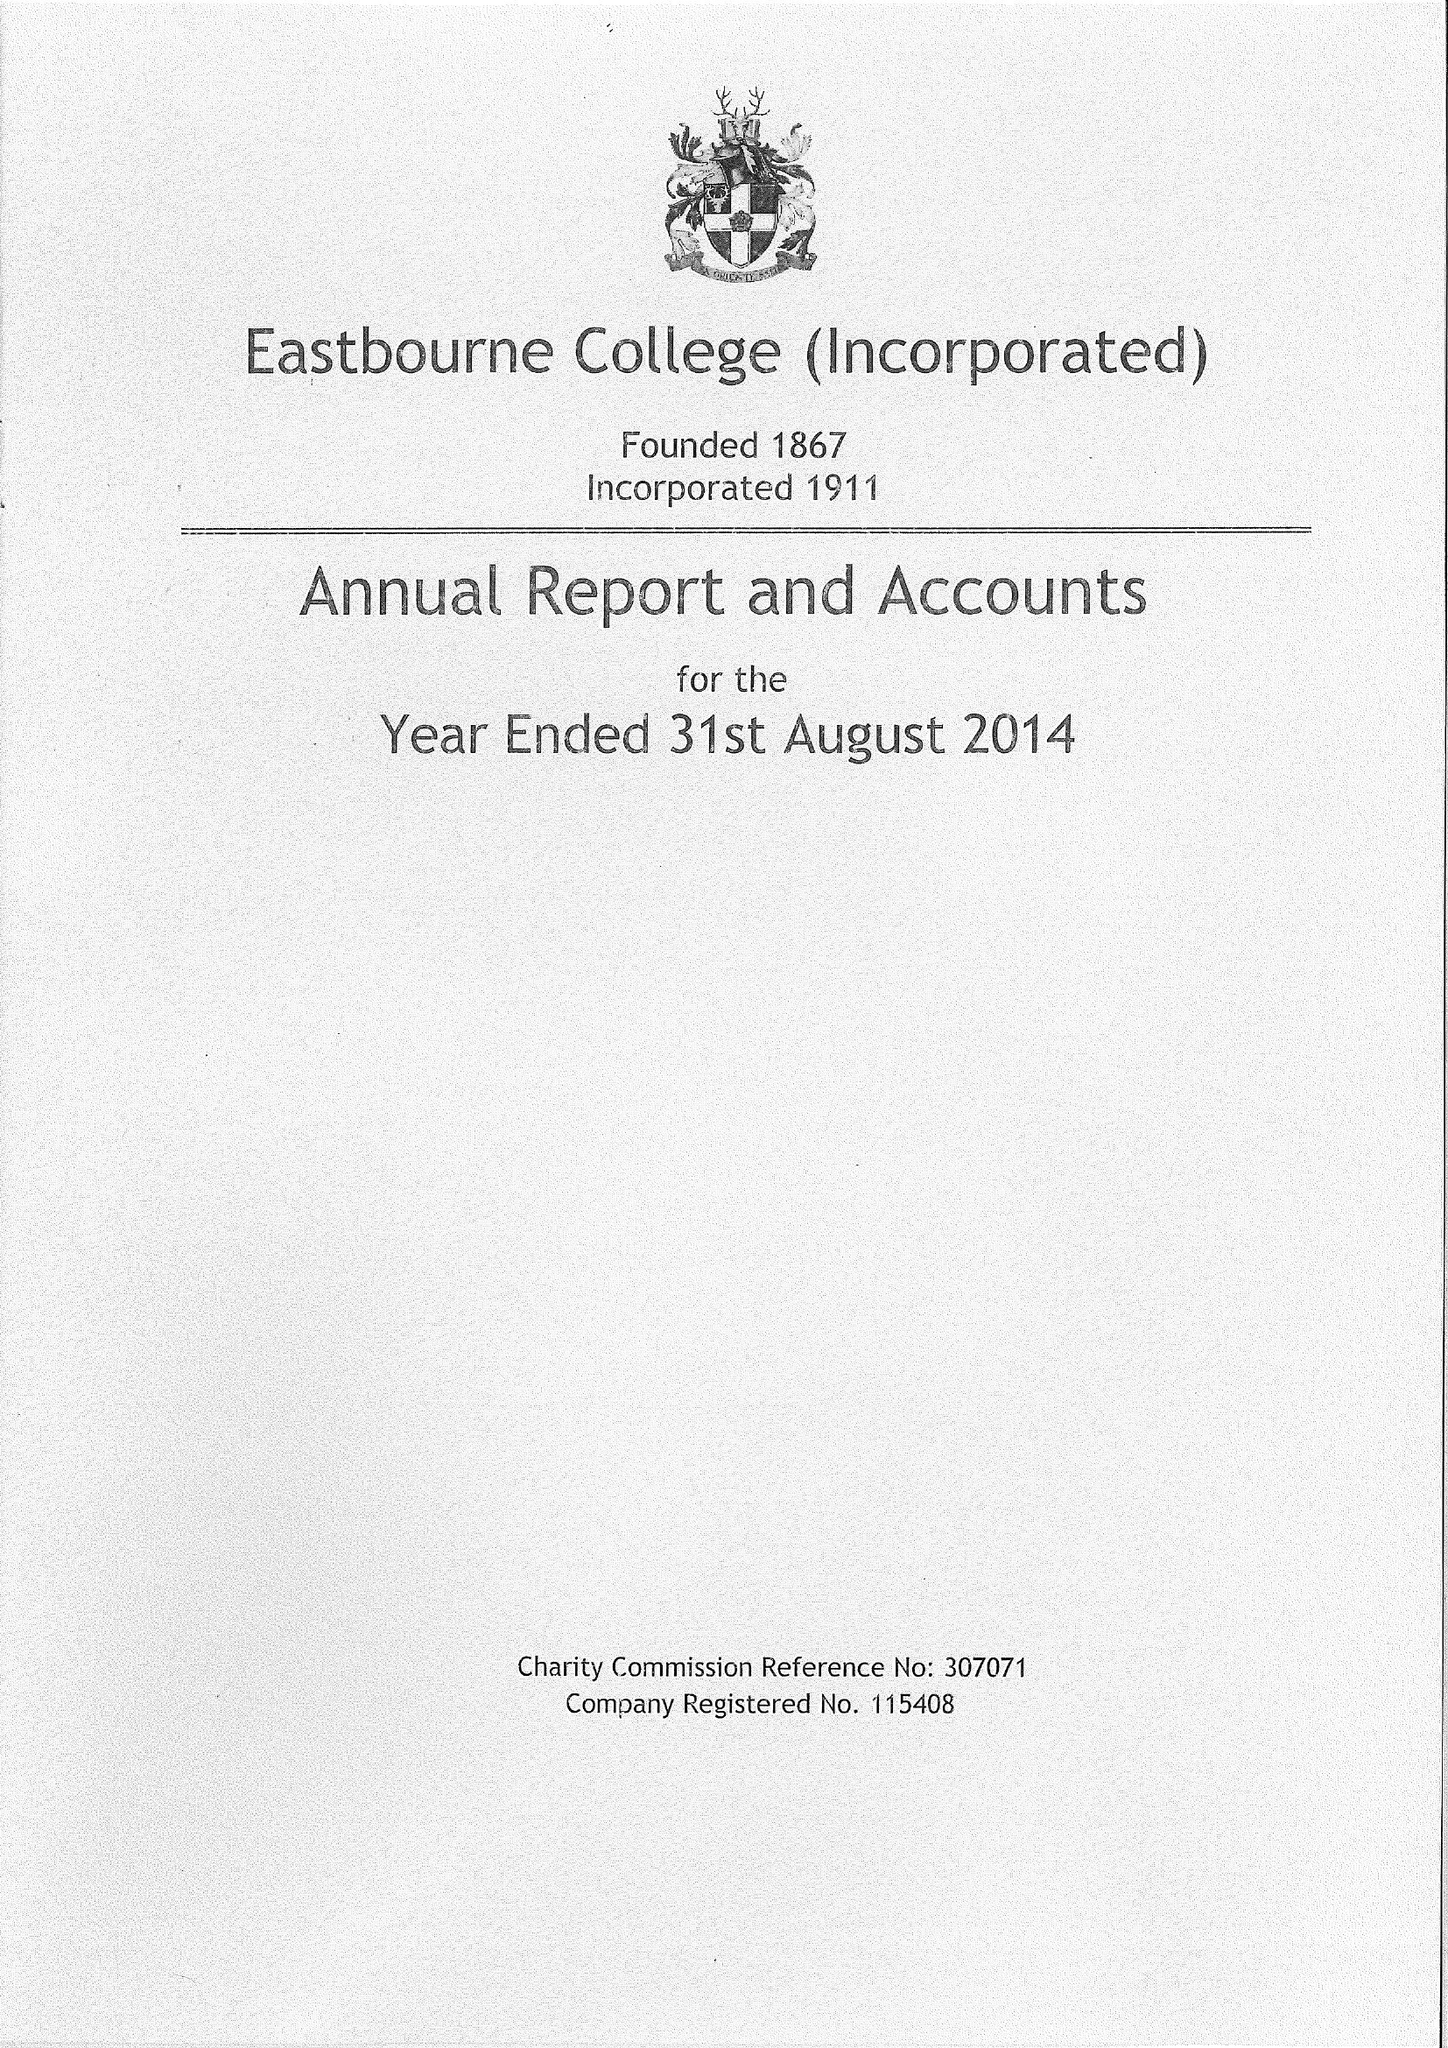What is the value for the address__postcode?
Answer the question using a single word or phrase. BN21 4JY 